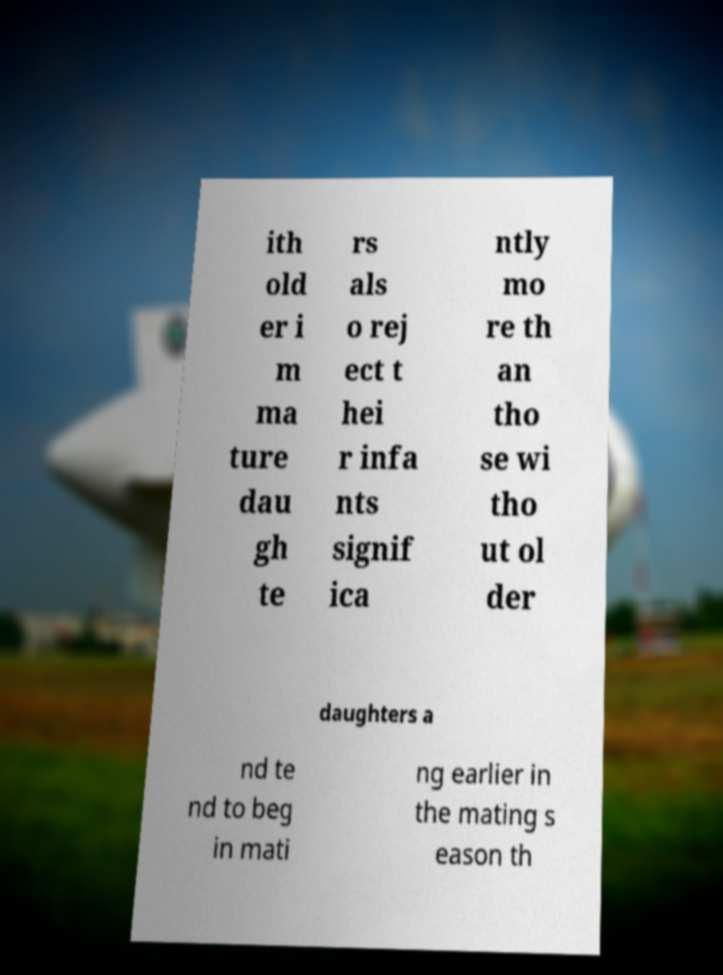Please read and relay the text visible in this image. What does it say? ith old er i m ma ture dau gh te rs als o rej ect t hei r infa nts signif ica ntly mo re th an tho se wi tho ut ol der daughters a nd te nd to beg in mati ng earlier in the mating s eason th 